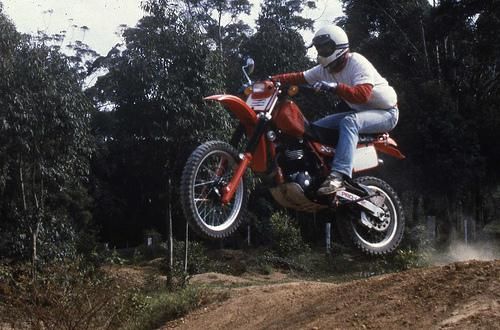Question: what is this person doing?
Choices:
A. Mowing grass.
B. Picking cotton.
C. Praying.
D. Motorcycle jumping.
Answer with the letter. Answer: D Question: what color is the helmet?
Choices:
A. Blue.
B. Silver.
C. White.
D. Grey.
Answer with the letter. Answer: C Question: how many riders are visible?
Choices:
A. One.
B. Two.
C. None.
D. Three.
Answer with the letter. Answer: A Question: when will the wheels be level?
Choices:
A. When they set it down.
B. After the jump.
C. When the ground is flat.
D. When the tire is aired.
Answer with the letter. Answer: B 